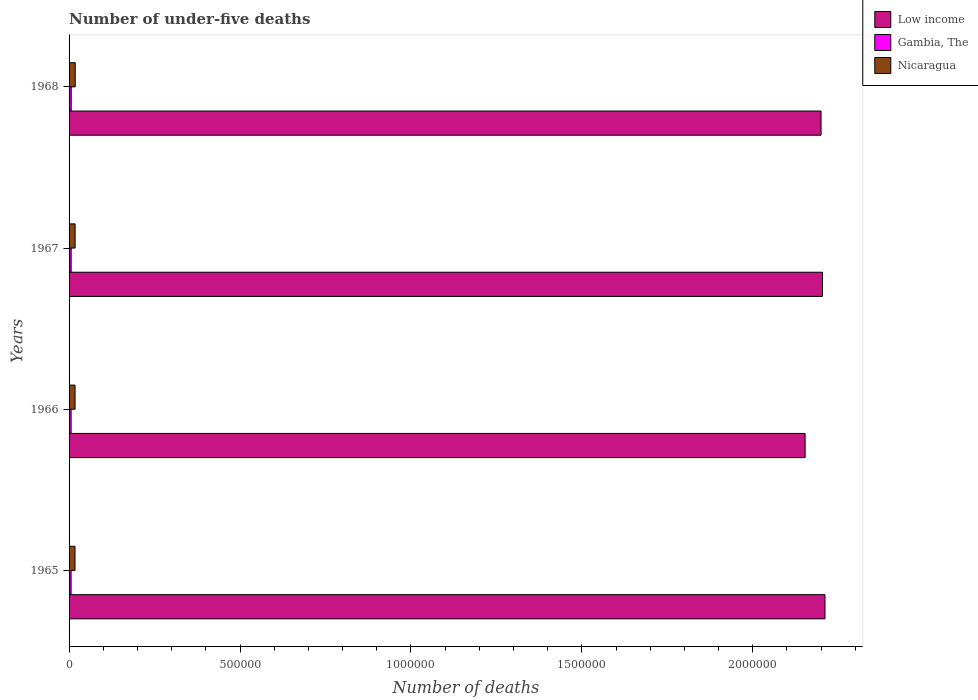How many different coloured bars are there?
Provide a succinct answer. 3. How many groups of bars are there?
Make the answer very short. 4. How many bars are there on the 3rd tick from the top?
Offer a very short reply. 3. What is the label of the 2nd group of bars from the top?
Offer a very short reply. 1967. In how many cases, is the number of bars for a given year not equal to the number of legend labels?
Provide a succinct answer. 0. What is the number of under-five deaths in Nicaragua in 1967?
Provide a short and direct response. 1.77e+04. Across all years, what is the maximum number of under-five deaths in Nicaragua?
Your answer should be compact. 1.80e+04. Across all years, what is the minimum number of under-five deaths in Nicaragua?
Offer a terse response. 1.73e+04. In which year was the number of under-five deaths in Gambia, The maximum?
Offer a terse response. 1968. In which year was the number of under-five deaths in Nicaragua minimum?
Provide a succinct answer. 1965. What is the total number of under-five deaths in Nicaragua in the graph?
Your answer should be compact. 7.05e+04. What is the difference between the number of under-five deaths in Low income in 1966 and that in 1967?
Your response must be concise. -5.08e+04. What is the difference between the number of under-five deaths in Low income in 1966 and the number of under-five deaths in Nicaragua in 1967?
Keep it short and to the point. 2.14e+06. What is the average number of under-five deaths in Low income per year?
Provide a short and direct response. 2.19e+06. In the year 1966, what is the difference between the number of under-five deaths in Nicaragua and number of under-five deaths in Gambia, The?
Make the answer very short. 1.16e+04. In how many years, is the number of under-five deaths in Gambia, The greater than 100000 ?
Provide a succinct answer. 0. What is the ratio of the number of under-five deaths in Gambia, The in 1965 to that in 1966?
Give a very brief answer. 0.99. Is the number of under-five deaths in Nicaragua in 1967 less than that in 1968?
Your answer should be compact. Yes. Is the difference between the number of under-five deaths in Nicaragua in 1965 and 1968 greater than the difference between the number of under-five deaths in Gambia, The in 1965 and 1968?
Make the answer very short. No. What is the difference between the highest and the second highest number of under-five deaths in Nicaragua?
Offer a very short reply. 247. What is the difference between the highest and the lowest number of under-five deaths in Nicaragua?
Offer a very short reply. 640. In how many years, is the number of under-five deaths in Low income greater than the average number of under-five deaths in Low income taken over all years?
Provide a succinct answer. 3. What does the 2nd bar from the bottom in 1965 represents?
Offer a very short reply. Gambia, The. How many bars are there?
Offer a terse response. 12. Are all the bars in the graph horizontal?
Your response must be concise. Yes. Where does the legend appear in the graph?
Offer a terse response. Top right. How many legend labels are there?
Keep it short and to the point. 3. How are the legend labels stacked?
Make the answer very short. Vertical. What is the title of the graph?
Your response must be concise. Number of under-five deaths. What is the label or title of the X-axis?
Offer a terse response. Number of deaths. What is the label or title of the Y-axis?
Your response must be concise. Years. What is the Number of deaths of Low income in 1965?
Your answer should be very brief. 2.21e+06. What is the Number of deaths in Gambia, The in 1965?
Make the answer very short. 5872. What is the Number of deaths of Nicaragua in 1965?
Offer a terse response. 1.73e+04. What is the Number of deaths in Low income in 1966?
Ensure brevity in your answer.  2.15e+06. What is the Number of deaths of Gambia, The in 1966?
Ensure brevity in your answer.  5918. What is the Number of deaths in Nicaragua in 1966?
Make the answer very short. 1.75e+04. What is the Number of deaths in Low income in 1967?
Your response must be concise. 2.20e+06. What is the Number of deaths in Gambia, The in 1967?
Give a very brief answer. 6036. What is the Number of deaths in Nicaragua in 1967?
Give a very brief answer. 1.77e+04. What is the Number of deaths in Low income in 1968?
Offer a very short reply. 2.20e+06. What is the Number of deaths of Gambia, The in 1968?
Make the answer very short. 6216. What is the Number of deaths of Nicaragua in 1968?
Your answer should be very brief. 1.80e+04. Across all years, what is the maximum Number of deaths in Low income?
Give a very brief answer. 2.21e+06. Across all years, what is the maximum Number of deaths of Gambia, The?
Give a very brief answer. 6216. Across all years, what is the maximum Number of deaths in Nicaragua?
Provide a succinct answer. 1.80e+04. Across all years, what is the minimum Number of deaths of Low income?
Keep it short and to the point. 2.15e+06. Across all years, what is the minimum Number of deaths in Gambia, The?
Your answer should be compact. 5872. Across all years, what is the minimum Number of deaths of Nicaragua?
Your answer should be compact. 1.73e+04. What is the total Number of deaths in Low income in the graph?
Give a very brief answer. 8.77e+06. What is the total Number of deaths of Gambia, The in the graph?
Provide a short and direct response. 2.40e+04. What is the total Number of deaths in Nicaragua in the graph?
Your answer should be very brief. 7.05e+04. What is the difference between the Number of deaths of Low income in 1965 and that in 1966?
Keep it short and to the point. 5.81e+04. What is the difference between the Number of deaths in Gambia, The in 1965 and that in 1966?
Keep it short and to the point. -46. What is the difference between the Number of deaths in Nicaragua in 1965 and that in 1966?
Offer a very short reply. -170. What is the difference between the Number of deaths of Low income in 1965 and that in 1967?
Your response must be concise. 7272. What is the difference between the Number of deaths of Gambia, The in 1965 and that in 1967?
Provide a short and direct response. -164. What is the difference between the Number of deaths of Nicaragua in 1965 and that in 1967?
Provide a succinct answer. -393. What is the difference between the Number of deaths in Low income in 1965 and that in 1968?
Your response must be concise. 1.15e+04. What is the difference between the Number of deaths in Gambia, The in 1965 and that in 1968?
Make the answer very short. -344. What is the difference between the Number of deaths in Nicaragua in 1965 and that in 1968?
Provide a succinct answer. -640. What is the difference between the Number of deaths in Low income in 1966 and that in 1967?
Offer a terse response. -5.08e+04. What is the difference between the Number of deaths in Gambia, The in 1966 and that in 1967?
Your answer should be compact. -118. What is the difference between the Number of deaths of Nicaragua in 1966 and that in 1967?
Ensure brevity in your answer.  -223. What is the difference between the Number of deaths of Low income in 1966 and that in 1968?
Ensure brevity in your answer.  -4.66e+04. What is the difference between the Number of deaths in Gambia, The in 1966 and that in 1968?
Give a very brief answer. -298. What is the difference between the Number of deaths of Nicaragua in 1966 and that in 1968?
Your answer should be compact. -470. What is the difference between the Number of deaths of Low income in 1967 and that in 1968?
Keep it short and to the point. 4248. What is the difference between the Number of deaths in Gambia, The in 1967 and that in 1968?
Your answer should be compact. -180. What is the difference between the Number of deaths of Nicaragua in 1967 and that in 1968?
Your answer should be compact. -247. What is the difference between the Number of deaths of Low income in 1965 and the Number of deaths of Gambia, The in 1966?
Keep it short and to the point. 2.21e+06. What is the difference between the Number of deaths of Low income in 1965 and the Number of deaths of Nicaragua in 1966?
Offer a very short reply. 2.19e+06. What is the difference between the Number of deaths of Gambia, The in 1965 and the Number of deaths of Nicaragua in 1966?
Ensure brevity in your answer.  -1.16e+04. What is the difference between the Number of deaths in Low income in 1965 and the Number of deaths in Gambia, The in 1967?
Give a very brief answer. 2.21e+06. What is the difference between the Number of deaths in Low income in 1965 and the Number of deaths in Nicaragua in 1967?
Your answer should be very brief. 2.19e+06. What is the difference between the Number of deaths in Gambia, The in 1965 and the Number of deaths in Nicaragua in 1967?
Offer a very short reply. -1.19e+04. What is the difference between the Number of deaths in Low income in 1965 and the Number of deaths in Gambia, The in 1968?
Ensure brevity in your answer.  2.20e+06. What is the difference between the Number of deaths of Low income in 1965 and the Number of deaths of Nicaragua in 1968?
Offer a terse response. 2.19e+06. What is the difference between the Number of deaths of Gambia, The in 1965 and the Number of deaths of Nicaragua in 1968?
Make the answer very short. -1.21e+04. What is the difference between the Number of deaths in Low income in 1966 and the Number of deaths in Gambia, The in 1967?
Give a very brief answer. 2.15e+06. What is the difference between the Number of deaths of Low income in 1966 and the Number of deaths of Nicaragua in 1967?
Provide a short and direct response. 2.14e+06. What is the difference between the Number of deaths in Gambia, The in 1966 and the Number of deaths in Nicaragua in 1967?
Offer a very short reply. -1.18e+04. What is the difference between the Number of deaths of Low income in 1966 and the Number of deaths of Gambia, The in 1968?
Make the answer very short. 2.15e+06. What is the difference between the Number of deaths in Low income in 1966 and the Number of deaths in Nicaragua in 1968?
Provide a succinct answer. 2.14e+06. What is the difference between the Number of deaths of Gambia, The in 1966 and the Number of deaths of Nicaragua in 1968?
Offer a very short reply. -1.21e+04. What is the difference between the Number of deaths in Low income in 1967 and the Number of deaths in Gambia, The in 1968?
Your response must be concise. 2.20e+06. What is the difference between the Number of deaths of Low income in 1967 and the Number of deaths of Nicaragua in 1968?
Give a very brief answer. 2.19e+06. What is the difference between the Number of deaths in Gambia, The in 1967 and the Number of deaths in Nicaragua in 1968?
Your answer should be very brief. -1.19e+04. What is the average Number of deaths of Low income per year?
Make the answer very short. 2.19e+06. What is the average Number of deaths of Gambia, The per year?
Give a very brief answer. 6010.5. What is the average Number of deaths of Nicaragua per year?
Offer a very short reply. 1.76e+04. In the year 1965, what is the difference between the Number of deaths of Low income and Number of deaths of Gambia, The?
Provide a succinct answer. 2.21e+06. In the year 1965, what is the difference between the Number of deaths in Low income and Number of deaths in Nicaragua?
Ensure brevity in your answer.  2.19e+06. In the year 1965, what is the difference between the Number of deaths in Gambia, The and Number of deaths in Nicaragua?
Offer a terse response. -1.15e+04. In the year 1966, what is the difference between the Number of deaths of Low income and Number of deaths of Gambia, The?
Your answer should be very brief. 2.15e+06. In the year 1966, what is the difference between the Number of deaths of Low income and Number of deaths of Nicaragua?
Your answer should be compact. 2.14e+06. In the year 1966, what is the difference between the Number of deaths in Gambia, The and Number of deaths in Nicaragua?
Provide a succinct answer. -1.16e+04. In the year 1967, what is the difference between the Number of deaths of Low income and Number of deaths of Gambia, The?
Make the answer very short. 2.20e+06. In the year 1967, what is the difference between the Number of deaths in Low income and Number of deaths in Nicaragua?
Offer a very short reply. 2.19e+06. In the year 1967, what is the difference between the Number of deaths of Gambia, The and Number of deaths of Nicaragua?
Your response must be concise. -1.17e+04. In the year 1968, what is the difference between the Number of deaths of Low income and Number of deaths of Gambia, The?
Your answer should be compact. 2.19e+06. In the year 1968, what is the difference between the Number of deaths of Low income and Number of deaths of Nicaragua?
Your answer should be compact. 2.18e+06. In the year 1968, what is the difference between the Number of deaths in Gambia, The and Number of deaths in Nicaragua?
Provide a short and direct response. -1.18e+04. What is the ratio of the Number of deaths of Nicaragua in 1965 to that in 1966?
Offer a terse response. 0.99. What is the ratio of the Number of deaths in Low income in 1965 to that in 1967?
Offer a terse response. 1. What is the ratio of the Number of deaths of Gambia, The in 1965 to that in 1967?
Give a very brief answer. 0.97. What is the ratio of the Number of deaths of Nicaragua in 1965 to that in 1967?
Provide a succinct answer. 0.98. What is the ratio of the Number of deaths of Low income in 1965 to that in 1968?
Give a very brief answer. 1.01. What is the ratio of the Number of deaths of Gambia, The in 1965 to that in 1968?
Provide a short and direct response. 0.94. What is the ratio of the Number of deaths in Nicaragua in 1965 to that in 1968?
Offer a very short reply. 0.96. What is the ratio of the Number of deaths of Low income in 1966 to that in 1967?
Your answer should be compact. 0.98. What is the ratio of the Number of deaths in Gambia, The in 1966 to that in 1967?
Provide a short and direct response. 0.98. What is the ratio of the Number of deaths in Nicaragua in 1966 to that in 1967?
Ensure brevity in your answer.  0.99. What is the ratio of the Number of deaths of Low income in 1966 to that in 1968?
Offer a terse response. 0.98. What is the ratio of the Number of deaths in Gambia, The in 1966 to that in 1968?
Offer a terse response. 0.95. What is the ratio of the Number of deaths in Nicaragua in 1966 to that in 1968?
Offer a very short reply. 0.97. What is the ratio of the Number of deaths in Nicaragua in 1967 to that in 1968?
Provide a succinct answer. 0.99. What is the difference between the highest and the second highest Number of deaths in Low income?
Give a very brief answer. 7272. What is the difference between the highest and the second highest Number of deaths in Gambia, The?
Your answer should be very brief. 180. What is the difference between the highest and the second highest Number of deaths in Nicaragua?
Your answer should be very brief. 247. What is the difference between the highest and the lowest Number of deaths in Low income?
Give a very brief answer. 5.81e+04. What is the difference between the highest and the lowest Number of deaths in Gambia, The?
Offer a terse response. 344. What is the difference between the highest and the lowest Number of deaths of Nicaragua?
Offer a very short reply. 640. 